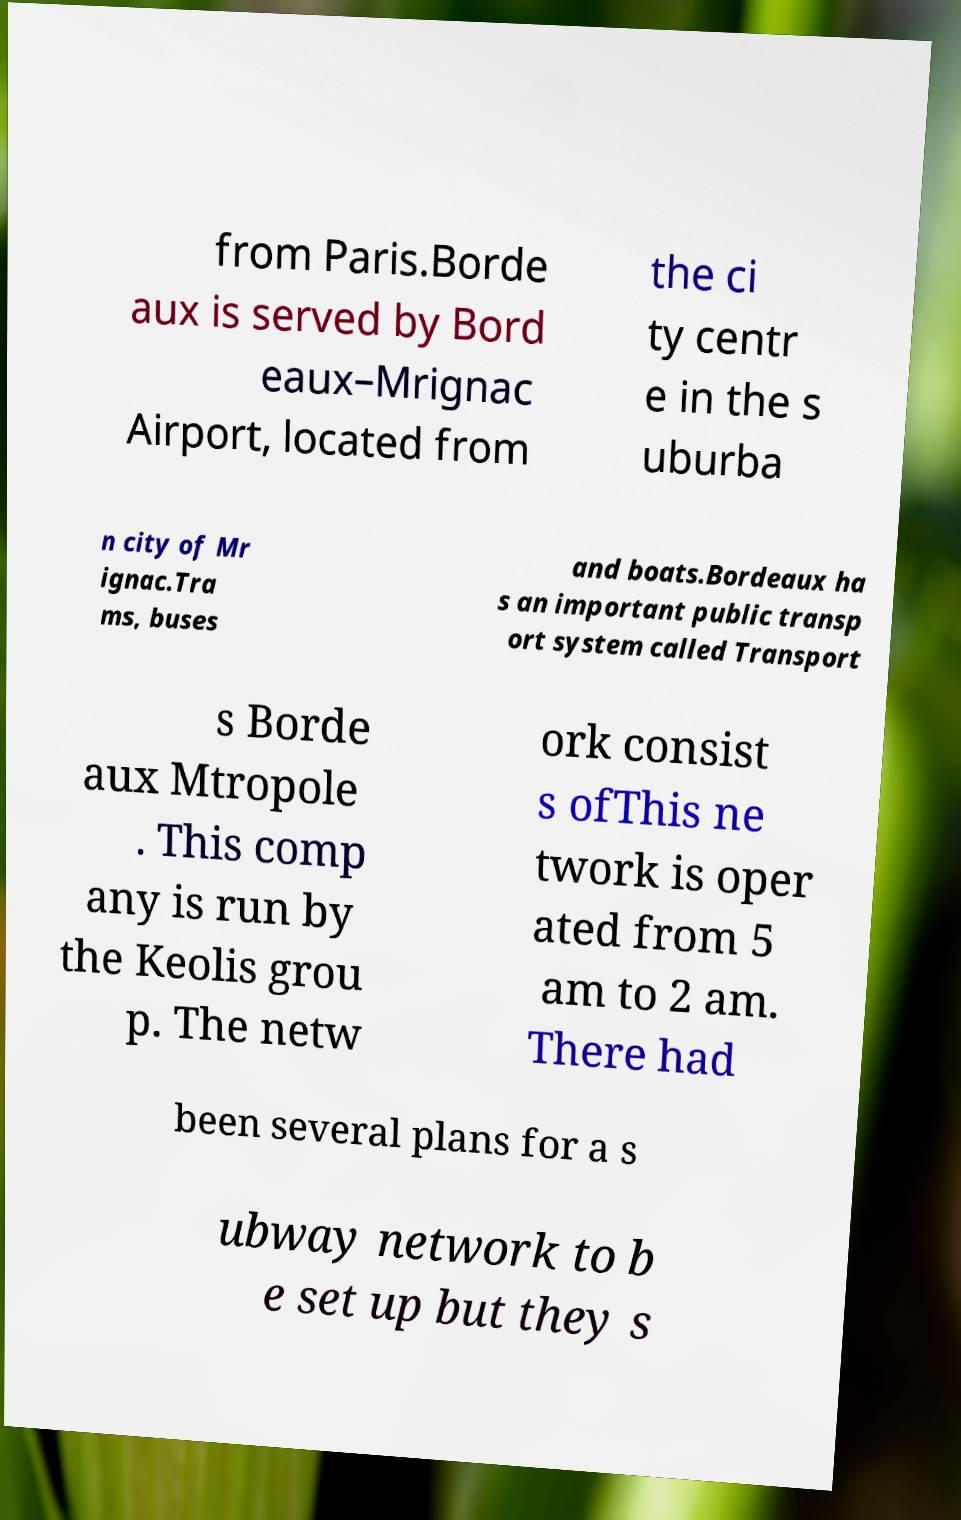I need the written content from this picture converted into text. Can you do that? from Paris.Borde aux is served by Bord eaux–Mrignac Airport, located from the ci ty centr e in the s uburba n city of Mr ignac.Tra ms, buses and boats.Bordeaux ha s an important public transp ort system called Transport s Borde aux Mtropole . This comp any is run by the Keolis grou p. The netw ork consist s ofThis ne twork is oper ated from 5 am to 2 am. There had been several plans for a s ubway network to b e set up but they s 